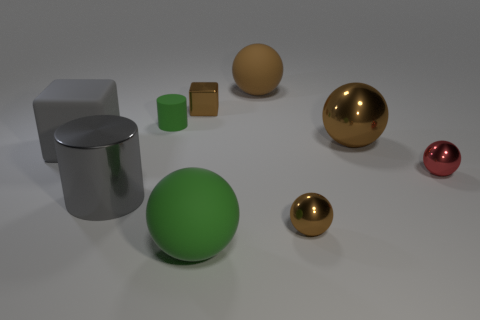Subtract all blue cylinders. How many brown balls are left? 3 Subtract all matte spheres. How many spheres are left? 3 Add 1 large gray metal objects. How many objects exist? 10 Subtract all red spheres. How many spheres are left? 4 Subtract all balls. How many objects are left? 4 Subtract all green balls. Subtract all yellow cylinders. How many balls are left? 4 Add 8 large shiny cylinders. How many large shiny cylinders are left? 9 Add 3 green balls. How many green balls exist? 4 Subtract 0 purple cylinders. How many objects are left? 9 Subtract all large brown spheres. Subtract all big brown metallic spheres. How many objects are left? 6 